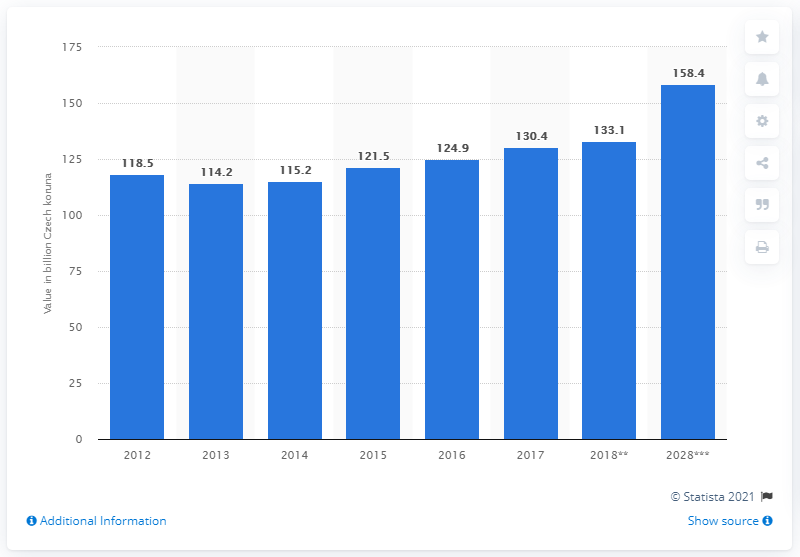Highlight a few significant elements in this photo. In 2018, the travel and tourism industry contributed 133.1% of Czech koruna to the country's Gross Domestic Product (GDP). 